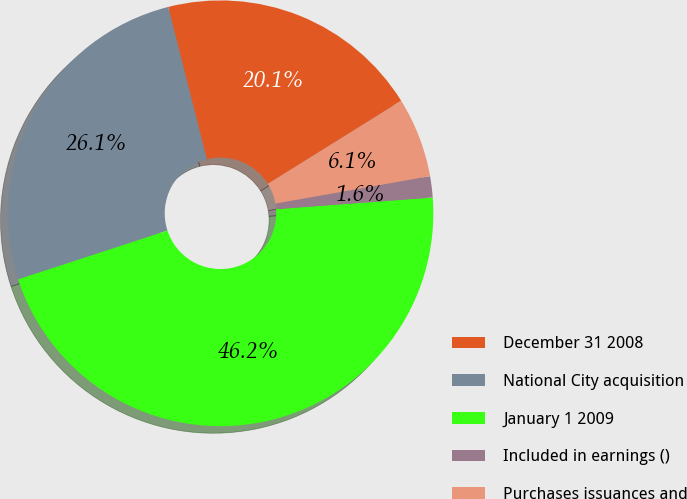Convert chart to OTSL. <chart><loc_0><loc_0><loc_500><loc_500><pie_chart><fcel>December 31 2008<fcel>National City acquisition<fcel>January 1 2009<fcel>Included in earnings ()<fcel>Purchases issuances and<nl><fcel>20.09%<fcel>26.07%<fcel>46.16%<fcel>1.61%<fcel>6.07%<nl></chart> 